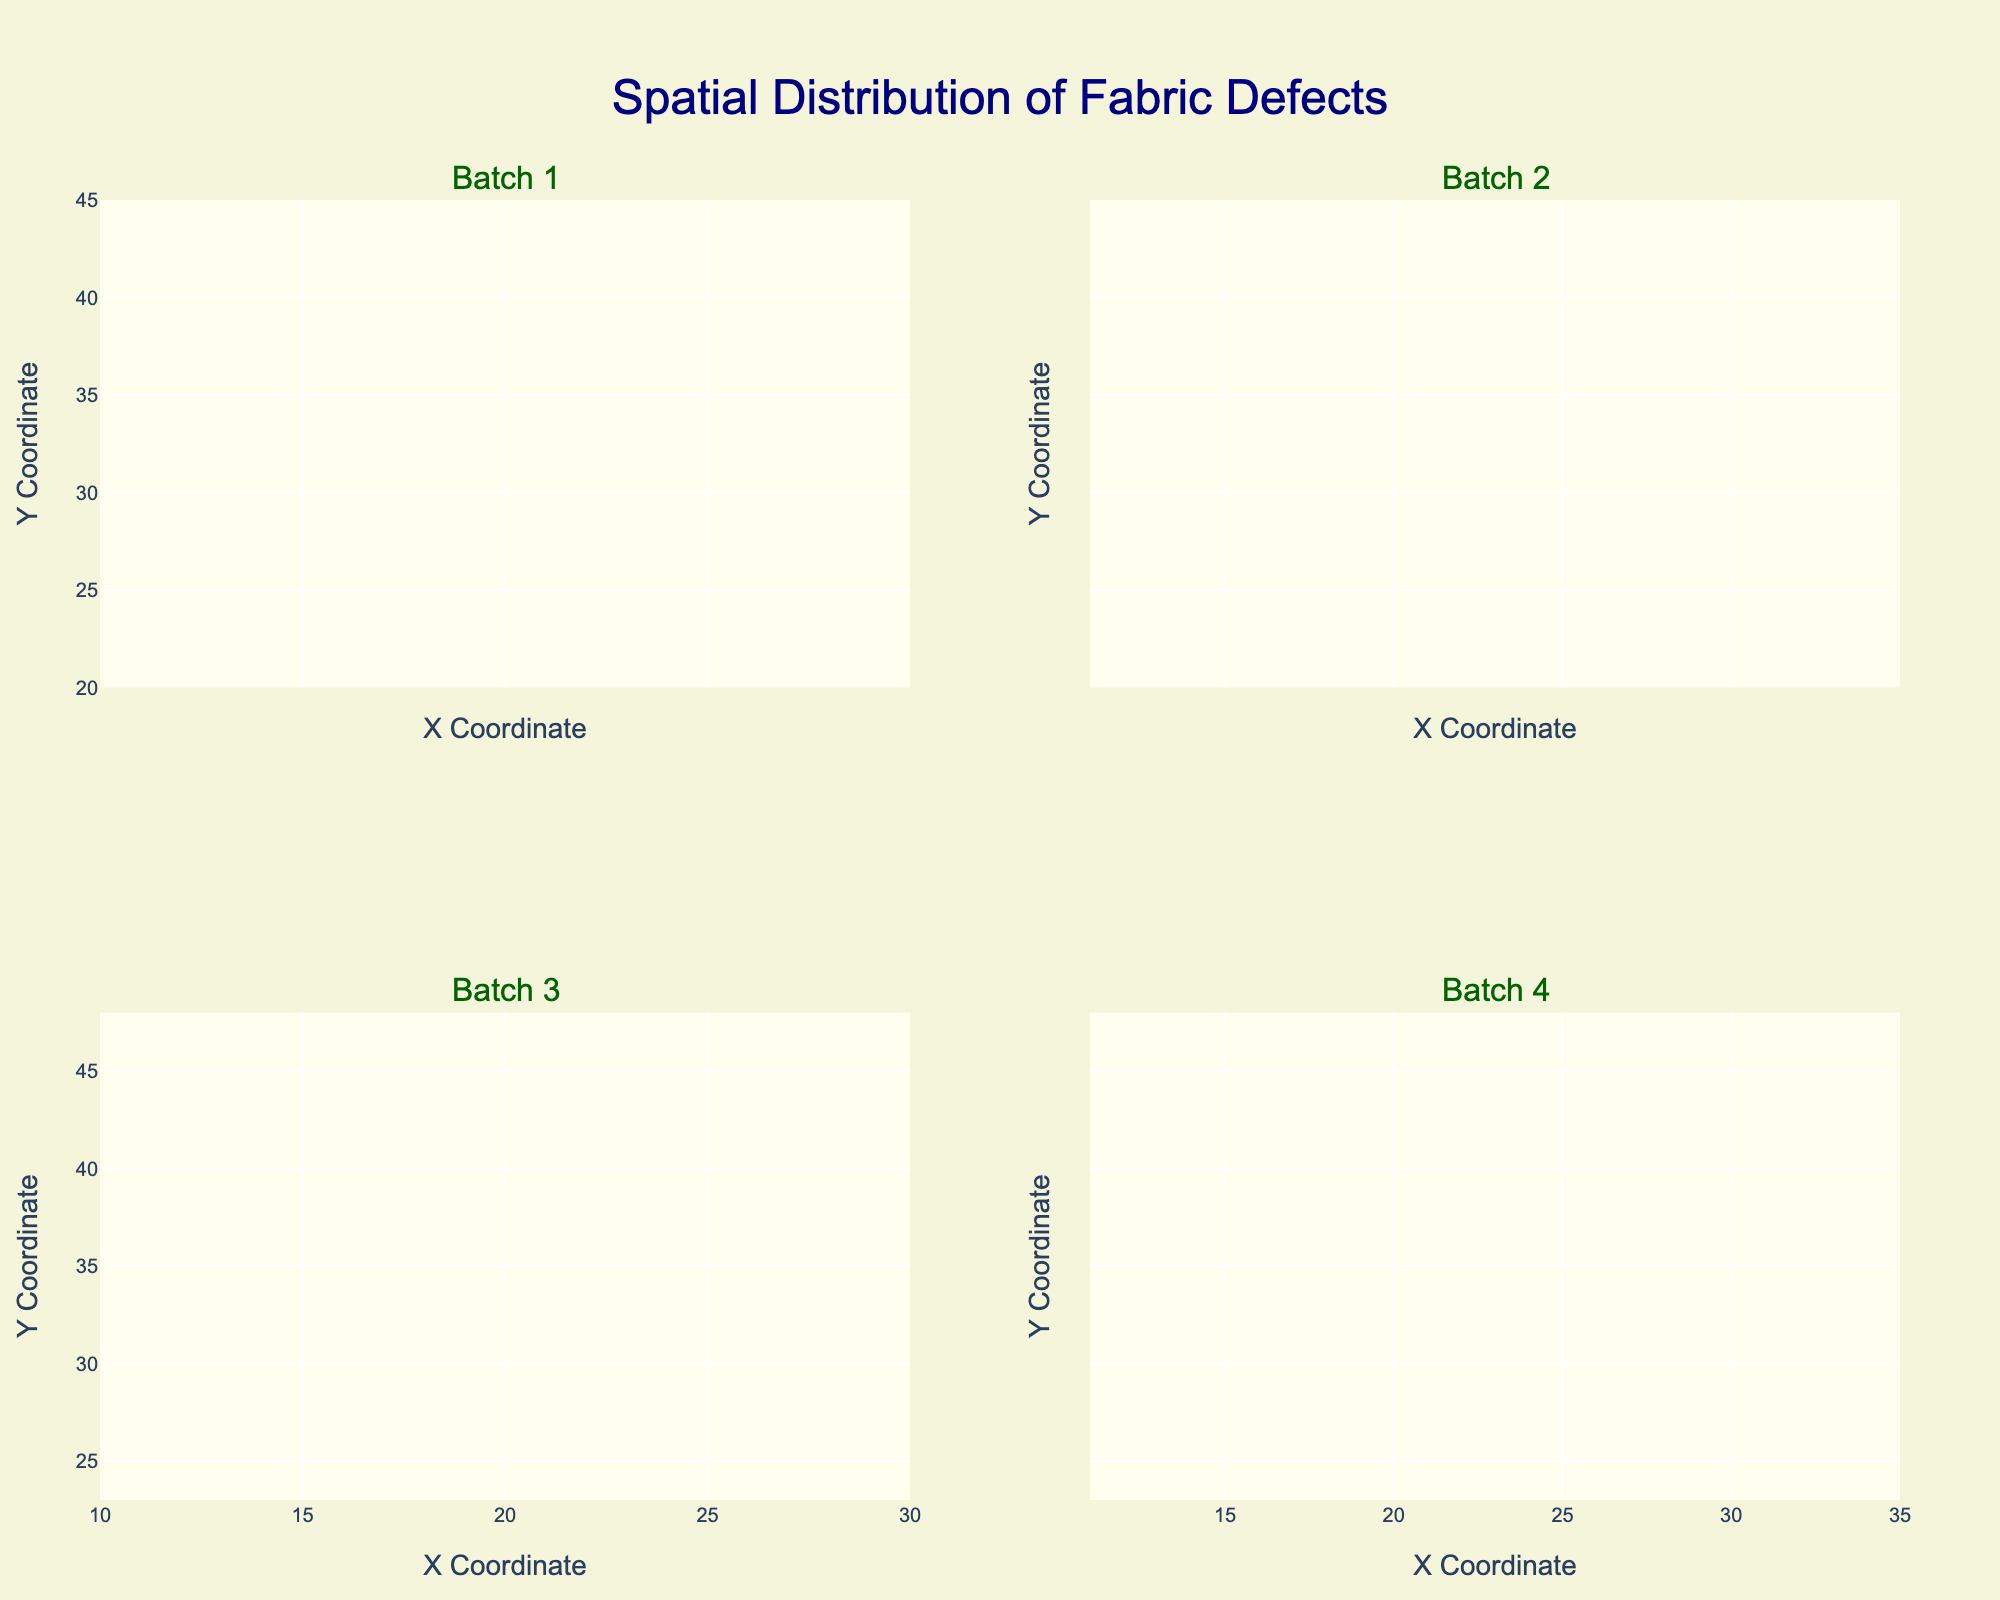What's the overall title of the figure? The overall title is located at the top of the figure and is written in a larger font size than the rest of the text. You can identify the title as it is a summarized description of the entire plot.
Answer: Spatial Distribution of Fabric Defects What are the labels of the X and Y axes? The X and Y axis labels are generally found along the respective axes. In this case, each subplot shares the axis labels. For the X axis, it's "X Coordinate" and for the Y axis, it's "Y Coordinate".
Answer: X Coordinate, Y Coordinate How many different defect types are displayed in the plots? By observing the color coding and the legend (if present), you can count the unique colors or notations that correspond to defect types. In this figure, there are four unique defect types: Stain (red), Tear (blue), WeaveError (green), ForeignParticle (purple).
Answer: 4 Which batch has the highest frequency of the 'Stain' defect? To determine which batch has the highest frequency of 'Stain', look at the contour plots for each batch and identify the peak values in the red colored contours. Batch 4 shows the highest peak frequency for 'Stain'.
Answer: Batch 4 Are the 'Tear' defects more concentrated in any specific area across the batches? Analyze the plots corresponding to each batch and look for concentrated areas (denoted by deeper blue contours) where 'Tear' defects appear. Notice the central position around coordinates (30, 40-45).
Answer: Yes, around (30, 40-45) Which batch has the least frequency of 'ForeignParticle' defects? By looking at the contour plots and noting the intensity of the purple areas representing 'ForeignParticle', identify the batch with the least concentrated or fewer intense areas. Batch 4 shows the least frequency for ‘ForeignParticle’.
Answer: Batch 4 Considering Batch 3, which defect type appears to have the highest frequency? Count the contour intensity levels of each color-coded defect in Batch 3's plot. The red colored defect (Stain) appears to be the most intense.
Answer: Stain Do 'WeaveError' defects show any distinct pattern in their spatial distribution? Examine the distribution of green contours across all subplots. Notice a pattern if they occur in similar locations or follow a particular trend. The 'WeaveError' defects seem slightly more frequent towards mid lower regions (near coordinates around 15-30).
Answer: Yes, mid lower regions Which batch has the most diverse types of defects? To figure this out, identify the batch where all four defect types (color-coded) are prominently visible in roughly equal proportions. Batch 1 shows all defect types reasonably spread across.
Answer: Batch 1 